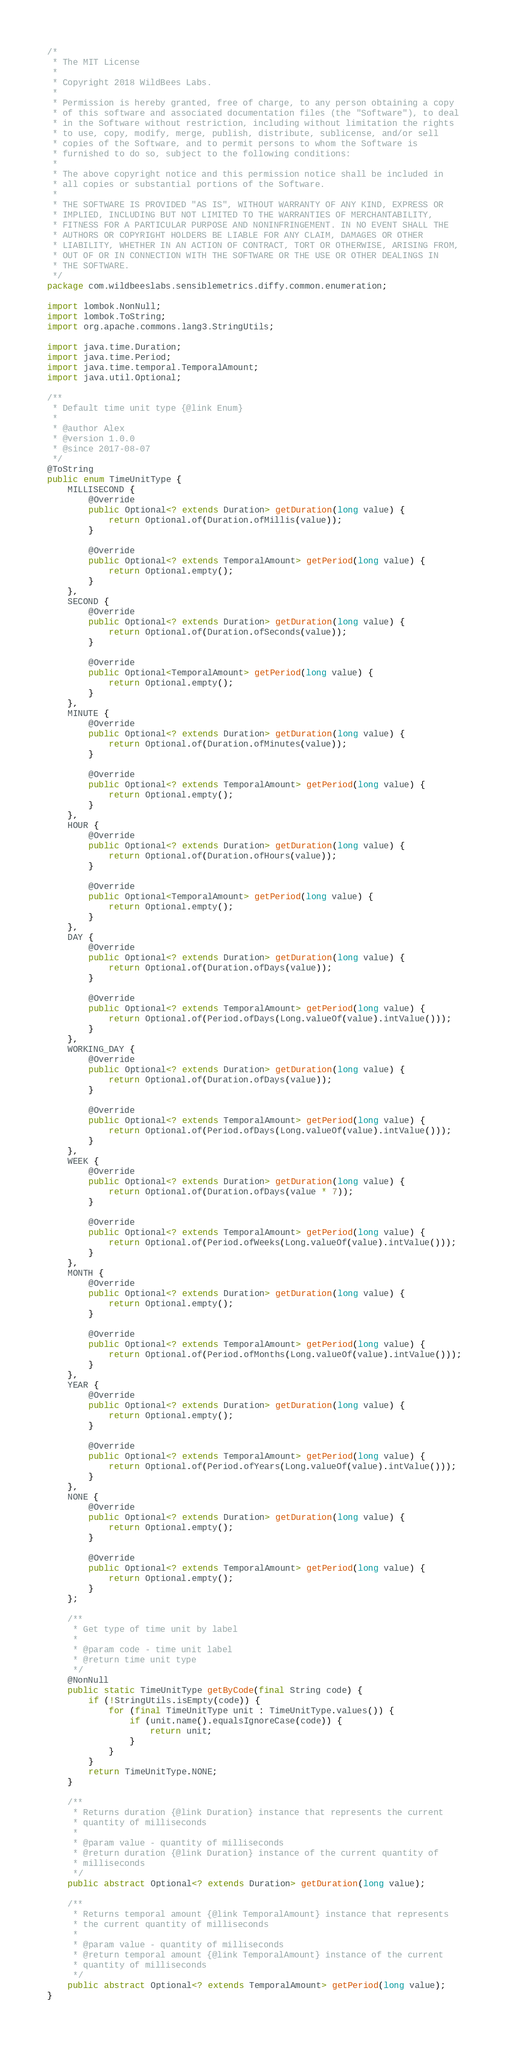<code> <loc_0><loc_0><loc_500><loc_500><_Java_>/*
 * The MIT License
 *
 * Copyright 2018 WildBees Labs.
 *
 * Permission is hereby granted, free of charge, to any person obtaining a copy
 * of this software and associated documentation files (the "Software"), to deal
 * in the Software without restriction, including without limitation the rights
 * to use, copy, modify, merge, publish, distribute, sublicense, and/or sell
 * copies of the Software, and to permit persons to whom the Software is
 * furnished to do so, subject to the following conditions:
 *
 * The above copyright notice and this permission notice shall be included in
 * all copies or substantial portions of the Software.
 *
 * THE SOFTWARE IS PROVIDED "AS IS", WITHOUT WARRANTY OF ANY KIND, EXPRESS OR
 * IMPLIED, INCLUDING BUT NOT LIMITED TO THE WARRANTIES OF MERCHANTABILITY,
 * FITNESS FOR A PARTICULAR PURPOSE AND NONINFRINGEMENT. IN NO EVENT SHALL THE
 * AUTHORS OR COPYRIGHT HOLDERS BE LIABLE FOR ANY CLAIM, DAMAGES OR OTHER
 * LIABILITY, WHETHER IN AN ACTION OF CONTRACT, TORT OR OTHERWISE, ARISING FROM,
 * OUT OF OR IN CONNECTION WITH THE SOFTWARE OR THE USE OR OTHER DEALINGS IN
 * THE SOFTWARE.
 */
package com.wildbeeslabs.sensiblemetrics.diffy.common.enumeration;

import lombok.NonNull;
import lombok.ToString;
import org.apache.commons.lang3.StringUtils;

import java.time.Duration;
import java.time.Period;
import java.time.temporal.TemporalAmount;
import java.util.Optional;

/**
 * Default time unit type {@link Enum}
 *
 * @author Alex
 * @version 1.0.0
 * @since 2017-08-07
 */
@ToString
public enum TimeUnitType {
    MILLISECOND {
        @Override
        public Optional<? extends Duration> getDuration(long value) {
            return Optional.of(Duration.ofMillis(value));
        }

        @Override
        public Optional<? extends TemporalAmount> getPeriod(long value) {
            return Optional.empty();
        }
    },
    SECOND {
        @Override
        public Optional<? extends Duration> getDuration(long value) {
            return Optional.of(Duration.ofSeconds(value));
        }

        @Override
        public Optional<TemporalAmount> getPeriod(long value) {
            return Optional.empty();
        }
    },
    MINUTE {
        @Override
        public Optional<? extends Duration> getDuration(long value) {
            return Optional.of(Duration.ofMinutes(value));
        }

        @Override
        public Optional<? extends TemporalAmount> getPeriod(long value) {
            return Optional.empty();
        }
    },
    HOUR {
        @Override
        public Optional<? extends Duration> getDuration(long value) {
            return Optional.of(Duration.ofHours(value));
        }

        @Override
        public Optional<TemporalAmount> getPeriod(long value) {
            return Optional.empty();
        }
    },
    DAY {
        @Override
        public Optional<? extends Duration> getDuration(long value) {
            return Optional.of(Duration.ofDays(value));
        }

        @Override
        public Optional<? extends TemporalAmount> getPeriod(long value) {
            return Optional.of(Period.ofDays(Long.valueOf(value).intValue()));
        }
    },
    WORKING_DAY {
        @Override
        public Optional<? extends Duration> getDuration(long value) {
            return Optional.of(Duration.ofDays(value));
        }

        @Override
        public Optional<? extends TemporalAmount> getPeriod(long value) {
            return Optional.of(Period.ofDays(Long.valueOf(value).intValue()));
        }
    },
    WEEK {
        @Override
        public Optional<? extends Duration> getDuration(long value) {
            return Optional.of(Duration.ofDays(value * 7));
        }

        @Override
        public Optional<? extends TemporalAmount> getPeriod(long value) {
            return Optional.of(Period.ofWeeks(Long.valueOf(value).intValue()));
        }
    },
    MONTH {
        @Override
        public Optional<? extends Duration> getDuration(long value) {
            return Optional.empty();
        }

        @Override
        public Optional<? extends TemporalAmount> getPeriod(long value) {
            return Optional.of(Period.ofMonths(Long.valueOf(value).intValue()));
        }
    },
    YEAR {
        @Override
        public Optional<? extends Duration> getDuration(long value) {
            return Optional.empty();
        }

        @Override
        public Optional<? extends TemporalAmount> getPeriod(long value) {
            return Optional.of(Period.ofYears(Long.valueOf(value).intValue()));
        }
    },
    NONE {
        @Override
        public Optional<? extends Duration> getDuration(long value) {
            return Optional.empty();
        }

        @Override
        public Optional<? extends TemporalAmount> getPeriod(long value) {
            return Optional.empty();
        }
    };

    /**
     * Get type of time unit by label
     *
     * @param code - time unit label
     * @return time unit type
     */
    @NonNull
    public static TimeUnitType getByCode(final String code) {
        if (!StringUtils.isEmpty(code)) {
            for (final TimeUnitType unit : TimeUnitType.values()) {
                if (unit.name().equalsIgnoreCase(code)) {
                    return unit;
                }
            }
        }
        return TimeUnitType.NONE;
    }

    /**
     * Returns duration {@link Duration} instance that represents the current
     * quantity of milliseconds
     *
     * @param value - quantity of milliseconds
     * @return duration {@link Duration} instance of the current quantity of
     * milliseconds
     */
    public abstract Optional<? extends Duration> getDuration(long value);

    /**
     * Returns temporal amount {@link TemporalAmount} instance that represents
     * the current quantity of milliseconds
     *
     * @param value - quantity of milliseconds
     * @return temporal amount {@link TemporalAmount} instance of the current
     * quantity of milliseconds
     */
    public abstract Optional<? extends TemporalAmount> getPeriod(long value);
}
</code> 